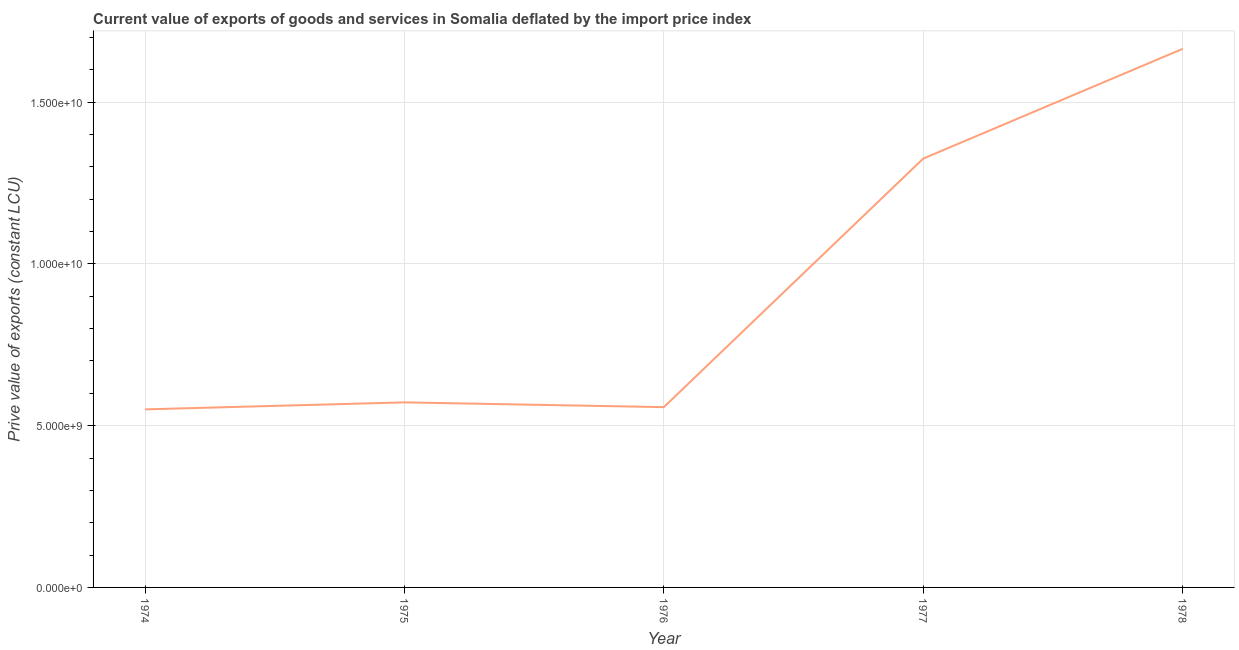What is the price value of exports in 1974?
Give a very brief answer. 5.50e+09. Across all years, what is the maximum price value of exports?
Your answer should be very brief. 1.66e+1. Across all years, what is the minimum price value of exports?
Keep it short and to the point. 5.50e+09. In which year was the price value of exports maximum?
Your answer should be very brief. 1978. In which year was the price value of exports minimum?
Offer a very short reply. 1974. What is the sum of the price value of exports?
Your response must be concise. 4.67e+1. What is the difference between the price value of exports in 1974 and 1978?
Your answer should be compact. -1.11e+1. What is the average price value of exports per year?
Make the answer very short. 9.34e+09. What is the median price value of exports?
Ensure brevity in your answer.  5.72e+09. In how many years, is the price value of exports greater than 7000000000 LCU?
Offer a terse response. 2. What is the ratio of the price value of exports in 1975 to that in 1977?
Keep it short and to the point. 0.43. Is the difference between the price value of exports in 1974 and 1977 greater than the difference between any two years?
Your answer should be compact. No. What is the difference between the highest and the second highest price value of exports?
Provide a short and direct response. 3.39e+09. What is the difference between the highest and the lowest price value of exports?
Provide a short and direct response. 1.11e+1. Does the price value of exports monotonically increase over the years?
Ensure brevity in your answer.  No. Are the values on the major ticks of Y-axis written in scientific E-notation?
Your answer should be very brief. Yes. Does the graph contain any zero values?
Keep it short and to the point. No. What is the title of the graph?
Your answer should be very brief. Current value of exports of goods and services in Somalia deflated by the import price index. What is the label or title of the Y-axis?
Your answer should be very brief. Prive value of exports (constant LCU). What is the Prive value of exports (constant LCU) in 1974?
Ensure brevity in your answer.  5.50e+09. What is the Prive value of exports (constant LCU) of 1975?
Offer a terse response. 5.72e+09. What is the Prive value of exports (constant LCU) of 1976?
Ensure brevity in your answer.  5.57e+09. What is the Prive value of exports (constant LCU) in 1977?
Offer a terse response. 1.33e+1. What is the Prive value of exports (constant LCU) in 1978?
Provide a short and direct response. 1.66e+1. What is the difference between the Prive value of exports (constant LCU) in 1974 and 1975?
Give a very brief answer. -2.16e+08. What is the difference between the Prive value of exports (constant LCU) in 1974 and 1976?
Provide a short and direct response. -6.90e+07. What is the difference between the Prive value of exports (constant LCU) in 1974 and 1977?
Ensure brevity in your answer.  -7.75e+09. What is the difference between the Prive value of exports (constant LCU) in 1974 and 1978?
Ensure brevity in your answer.  -1.11e+1. What is the difference between the Prive value of exports (constant LCU) in 1975 and 1976?
Your answer should be very brief. 1.47e+08. What is the difference between the Prive value of exports (constant LCU) in 1975 and 1977?
Offer a terse response. -7.54e+09. What is the difference between the Prive value of exports (constant LCU) in 1975 and 1978?
Make the answer very short. -1.09e+1. What is the difference between the Prive value of exports (constant LCU) in 1976 and 1977?
Make the answer very short. -7.68e+09. What is the difference between the Prive value of exports (constant LCU) in 1976 and 1978?
Make the answer very short. -1.11e+1. What is the difference between the Prive value of exports (constant LCU) in 1977 and 1978?
Offer a very short reply. -3.39e+09. What is the ratio of the Prive value of exports (constant LCU) in 1974 to that in 1977?
Provide a short and direct response. 0.41. What is the ratio of the Prive value of exports (constant LCU) in 1974 to that in 1978?
Your answer should be compact. 0.33. What is the ratio of the Prive value of exports (constant LCU) in 1975 to that in 1976?
Provide a short and direct response. 1.03. What is the ratio of the Prive value of exports (constant LCU) in 1975 to that in 1977?
Offer a very short reply. 0.43. What is the ratio of the Prive value of exports (constant LCU) in 1975 to that in 1978?
Provide a succinct answer. 0.34. What is the ratio of the Prive value of exports (constant LCU) in 1976 to that in 1977?
Offer a very short reply. 0.42. What is the ratio of the Prive value of exports (constant LCU) in 1976 to that in 1978?
Make the answer very short. 0.34. What is the ratio of the Prive value of exports (constant LCU) in 1977 to that in 1978?
Keep it short and to the point. 0.8. 